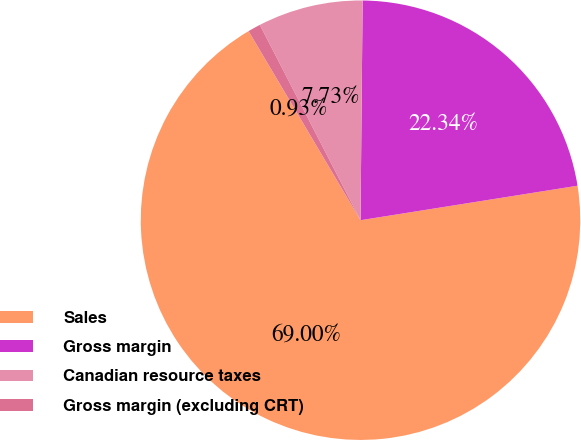<chart> <loc_0><loc_0><loc_500><loc_500><pie_chart><fcel>Sales<fcel>Gross margin<fcel>Canadian resource taxes<fcel>Gross margin (excluding CRT)<nl><fcel>69.0%<fcel>22.34%<fcel>7.73%<fcel>0.93%<nl></chart> 